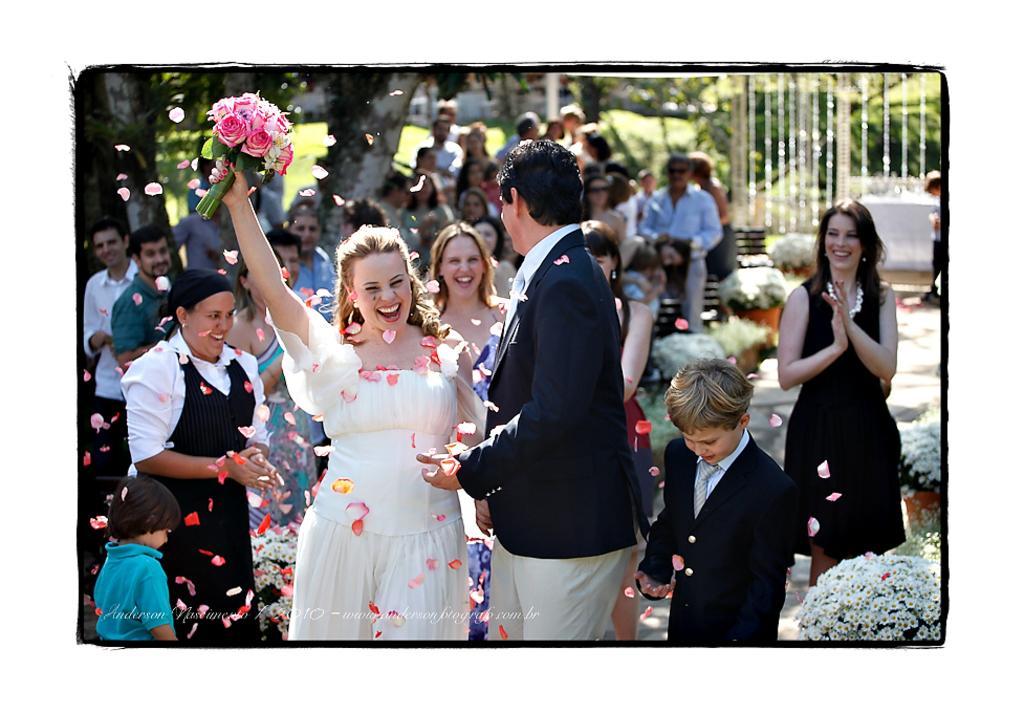Can you describe this image briefly? This picture shows few people Standing and we see a woman holding flowers in her hand and we see few trees and a metal fence and we see smile on their faces and few flower pots and we see watermark at the bottom of the picture. 